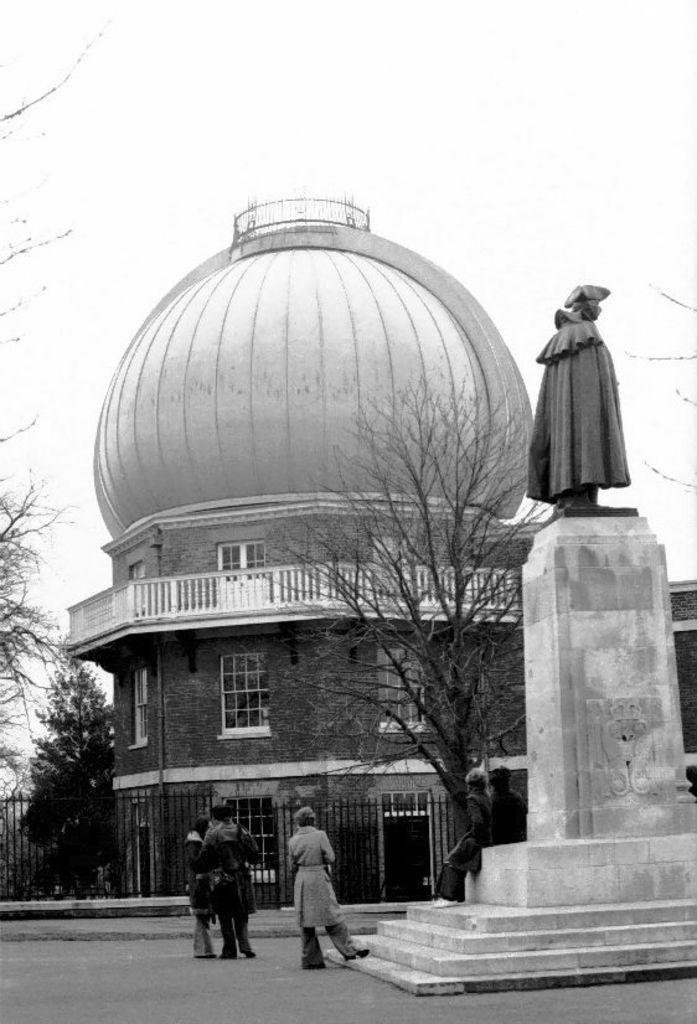What is the color scheme of the image? The image is black and white. What type of structure can be seen in the image? There is a building with windows in the image. What is another object present in the image? There is a statue in the image. Can you describe the people in the image? There is a group of people in the image. What type of vegetation is visible in the image? There are trees in the image. What architectural feature can be seen in the image? There is a fence in the image. What is visible in the background of the image? The sky is visible in the image. What type of hospital is depicted in the image? There is no hospital present in the image. 